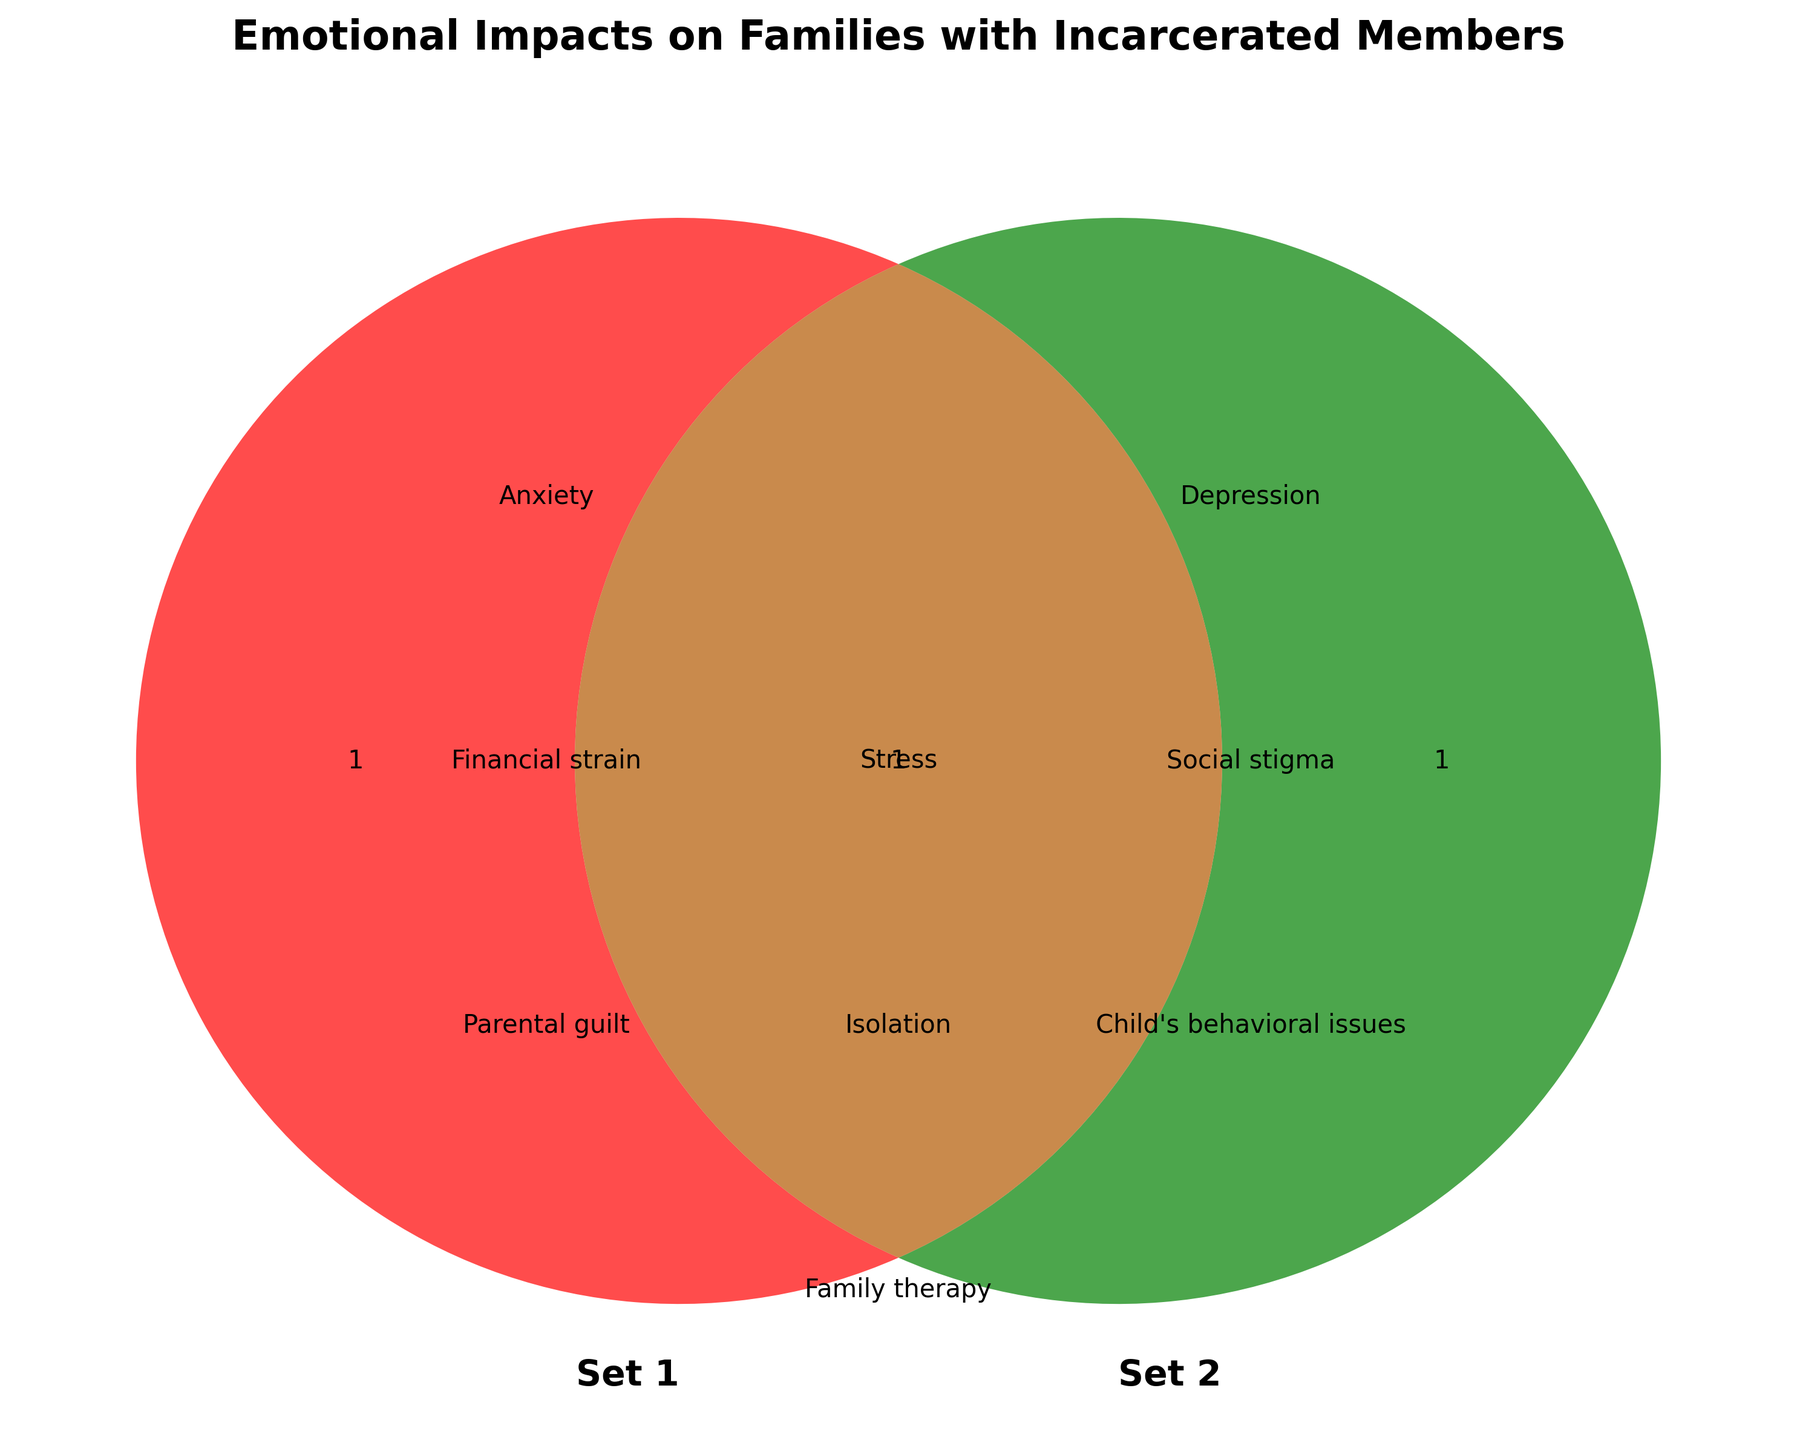What are the two sets labeled in the Venn diagram? The Venn diagram compares two groups, which are usually labeled on the diagram.
Answer: Set 1 and Set 2 What is the title of the Venn diagram? The title is usually displayed at the top center of the diagram. It describes the purpose or nature of the diagram.
Answer: Emotional Impacts on Families with Incarcerated Members Which emotional impacts are common between the two sets? The intersection area of the Venn diagram shows common elements shared by both sets. Read the items listed in the overlapping section.
Answer: Stress, Isolation, Family therapy, Resource sharing, Maintaining relationships, Counseling services What kinds of emotional impacts are unique to Set 1? The unique aspects of a set in a Venn diagram are those not shared with the other set. Look at the left circle's non-overlapping area.
Answer: Anxiety, Financial strain, Parental guilt, Support groups, Visitation challenges, Coping mechanisms How many different categories are listed in total across both sets and their intersection areas? Count the unique items in Set1, Set2, and their intersection.
Answer: 18 Which set includes 'Depression'? Identify which set the term 'Depression' belongs to by checking its location in the Venn diagram.
Answer: Set 2 Which emotional impacts in Set 2 are not present in the intersection? Look at the elements in the right circle excluding those in the overlapping section.
Answer: Depression, Social stigma, Child's behavioral issues, Legal advocacy, Communication barriers, Educational support for children What are the three emotional impacts represented in the intersection? The intersection area of the Venn diagram includes items common to both sets. Generally, these are fewer in number due to the shared nature. List any three of those.
Answer: Stress, Isolation, Family therapy Which emotional impact is related to child behavior and which set does it belong to? Identify the impact related to child behavior by scanning through the terms and determining its set based on location.
Answer: Child's behavioral issues, Set 2 How many kinds of support services are mentioned in the entire diagram? Scan through all text entries and count those specifically listed as services or supportive mechanisms.
Answer: 4 